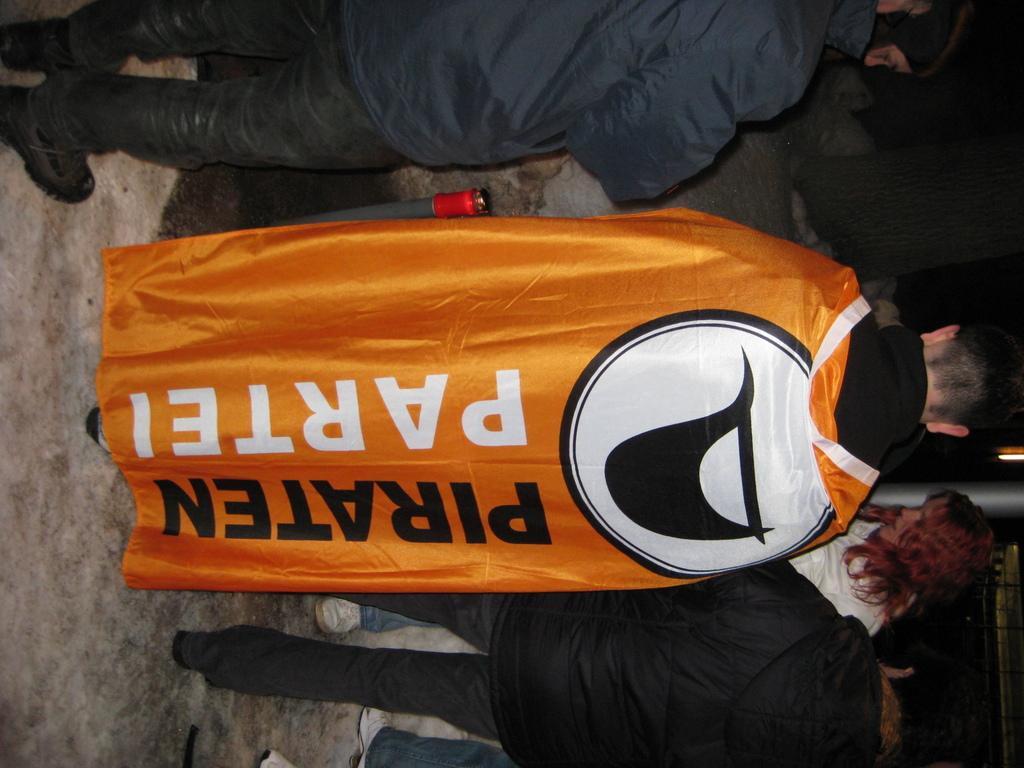What does the orange robe say?
Give a very brief answer. Piraten partei. What is the word in black?
Provide a succinct answer. Piraten. 